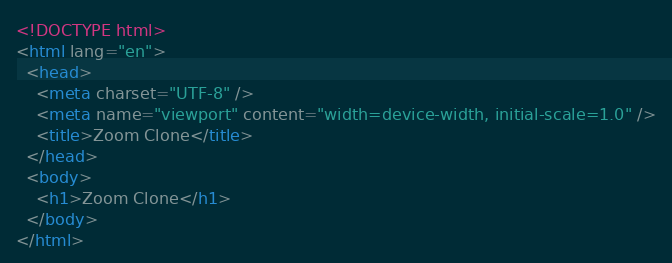<code> <loc_0><loc_0><loc_500><loc_500><_HTML_><!DOCTYPE html>
<html lang="en">
  <head>
    <meta charset="UTF-8" />
    <meta name="viewport" content="width=device-width, initial-scale=1.0" />
    <title>Zoom Clone</title>
  </head>
  <body>
    <h1>Zoom Clone</h1>
  </body>
</html>
</code> 